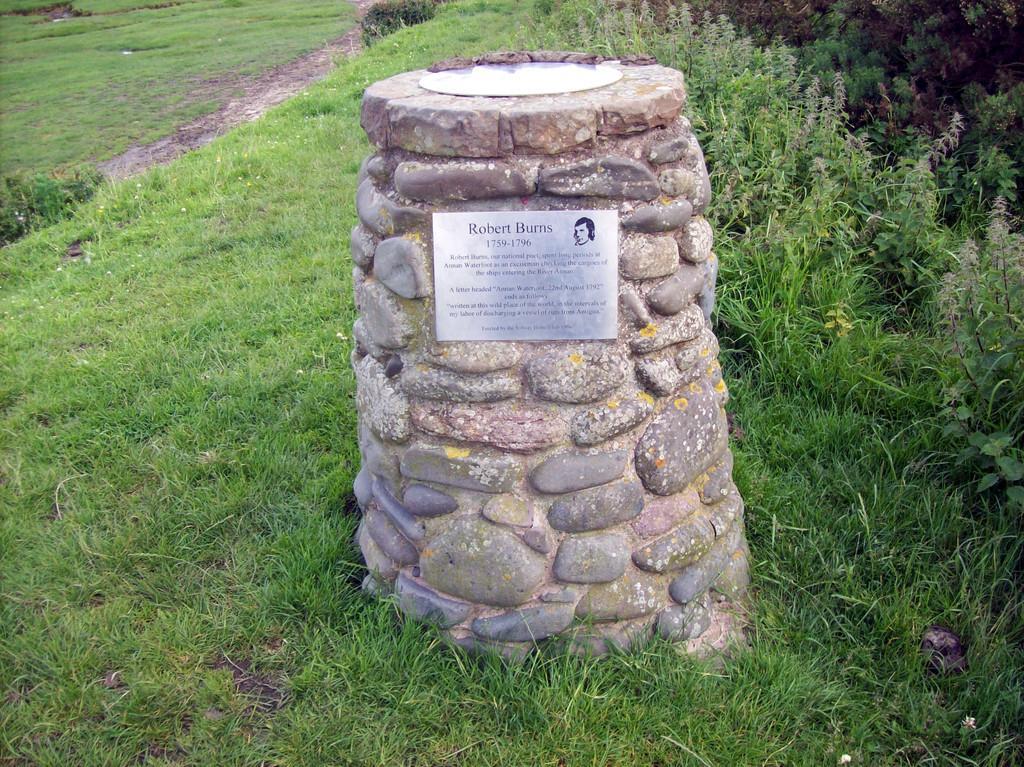How would you summarize this image in a sentence or two? There is a headstone in the center of the image on the grassland and there is greenery around the area. 